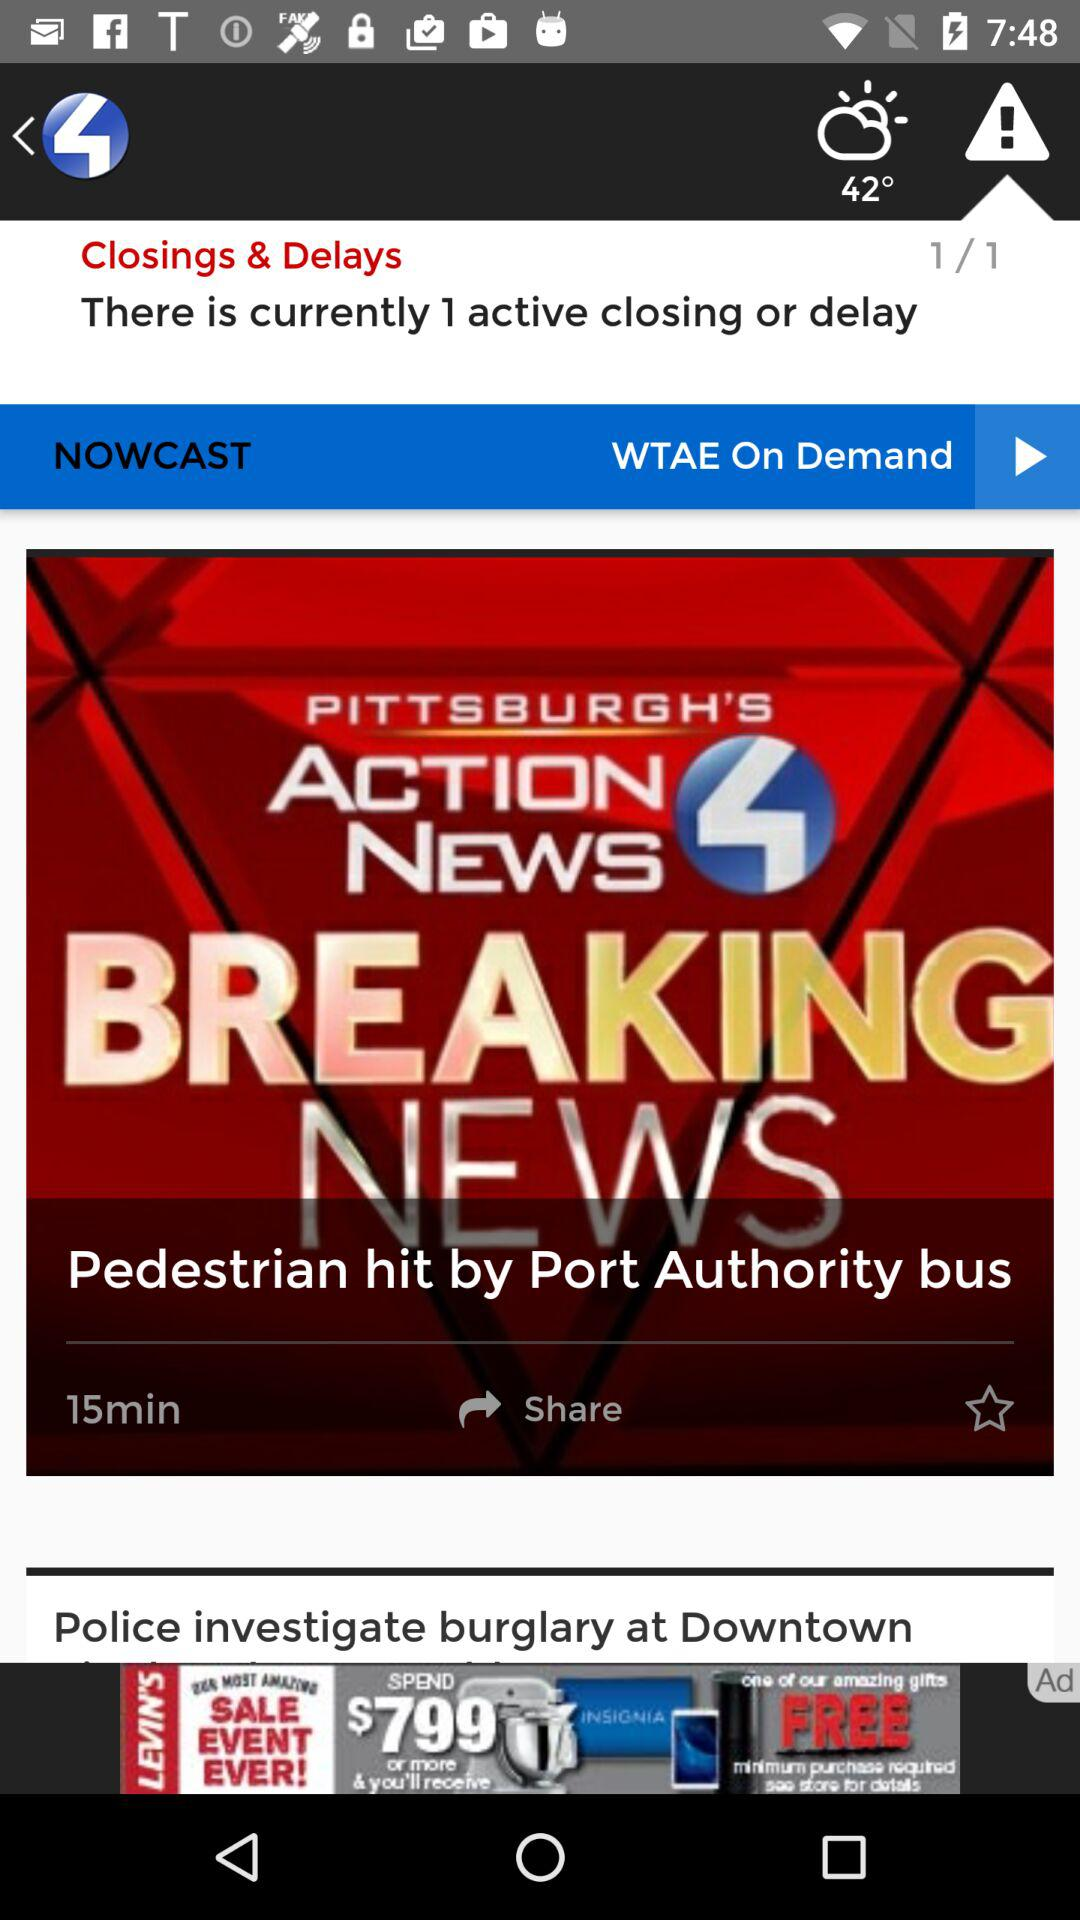When was the breaking news "Pedestrian hit by Port Authority bus" published? The breaking news was published 15 minutes ago. 